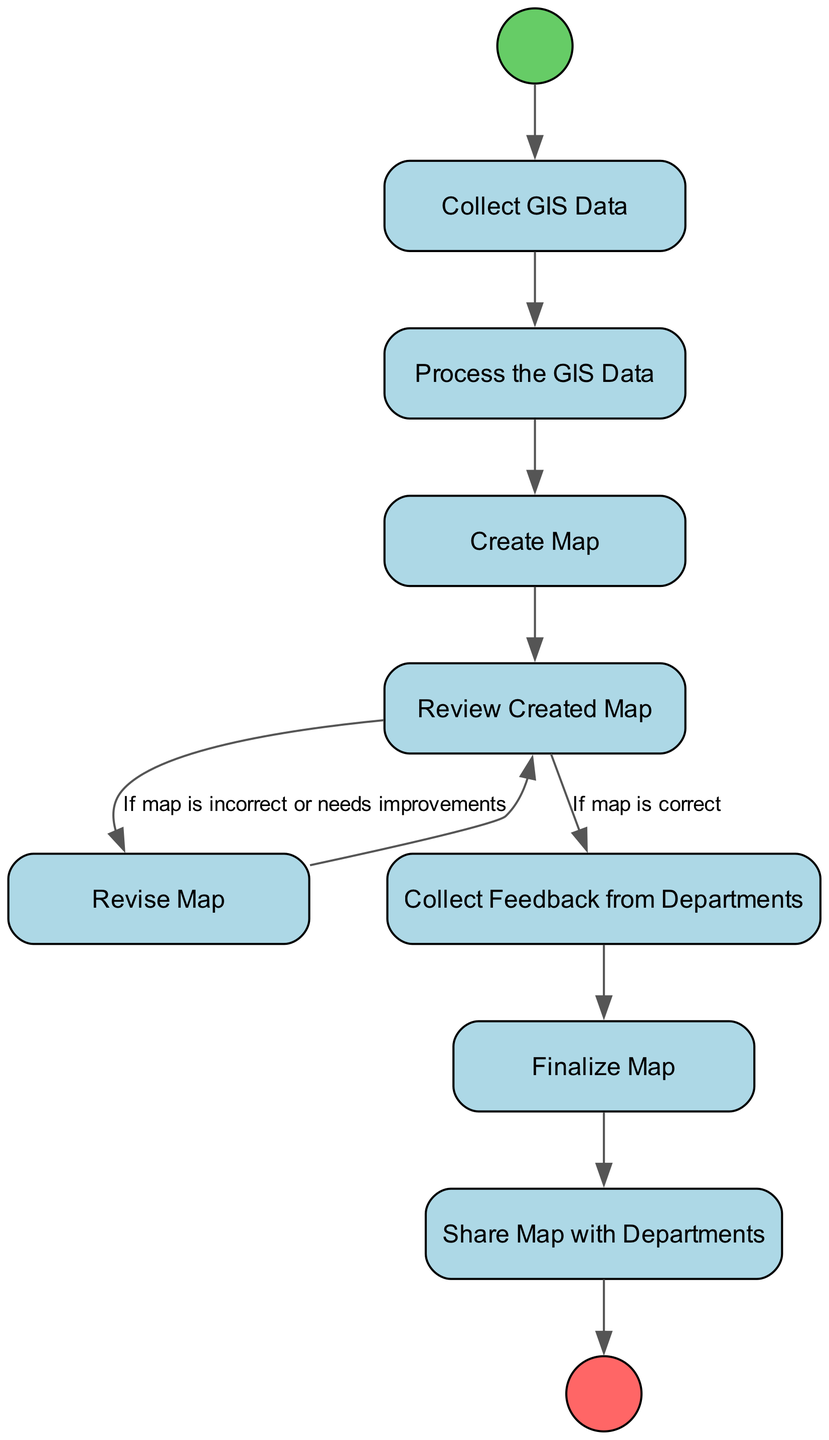What is the first activity in the diagram? The first activity is marked by the StartEvent node, which leads directly to "Collect GIS Data." Thus, the first activity is identified by following the flow from the start node to the first rectangular node.
Answer: Collect GIS Data How many activities are there in total? By counting all the nodes labeled as activities (excluding start and end nodes), there are ten activities listed: "Collect GIS Data," "Process the GIS Data," "Create Map," "Review Created Map," "Revise Map," "Collect Feedback from Departments," "Finalize Map," and "Share Map with Departments." Therefore, including the start and end, there are ten nodes in total.
Answer: Ten What happens to the map if it is correct after review? If the map is correct after the review, the flow continues directly to "Collect Feedback from Departments." The connection can be traced from "Review Created Map" to "Collect Feedback from Departments" without revising the map.
Answer: Collect Feedback from Departments What is the last activity before the end event? The last activity that occurs before the end event is "Share Map with Departments," which is the final step following "Finalize Map." Tracing the flow from "Finalize Map" leads directly to "Share Map with Departments."
Answer: Share Map with Departments What occurs if the map is found to be incorrect? If the map is found to be incorrect or needs improvements after the review, the flow directs to "Revise Map." This can be identified by following the flow from "Review Created Map" to "Revise Map" based on the condition provided.
Answer: Revise Map What is the relationship between feedback collection and map finalization? The relationship is sequential; "Collect Feedback from Departments" must occur before "Finalize Map." This can be deduced by following the directed flow from "Collect Feedback from Departments" to "Finalize Map."
Answer: Sequential How many flows lead to the map revision activity? There is one flow leading to the "Revise Map" activity, specifically from "Review Created Map" if the map is incorrect. It’s the only directed path that leads into "Revise Map." Thus, obtaining the count reveals a singular flow for this activity.
Answer: One 